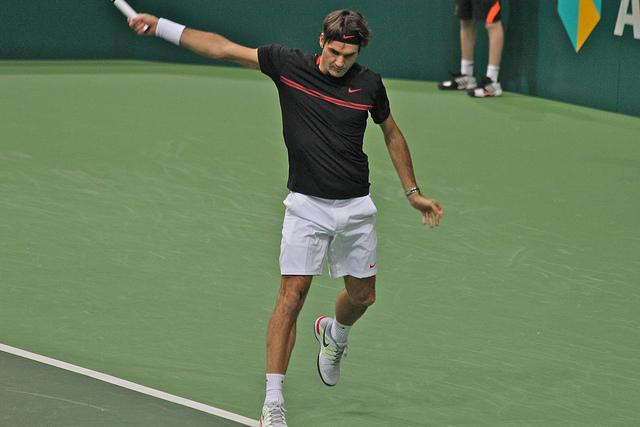What is the man in the foreground wearing on his feet?

Choices:
A) sandals
B) sneakers
C) boots
D) shoes sneakers 